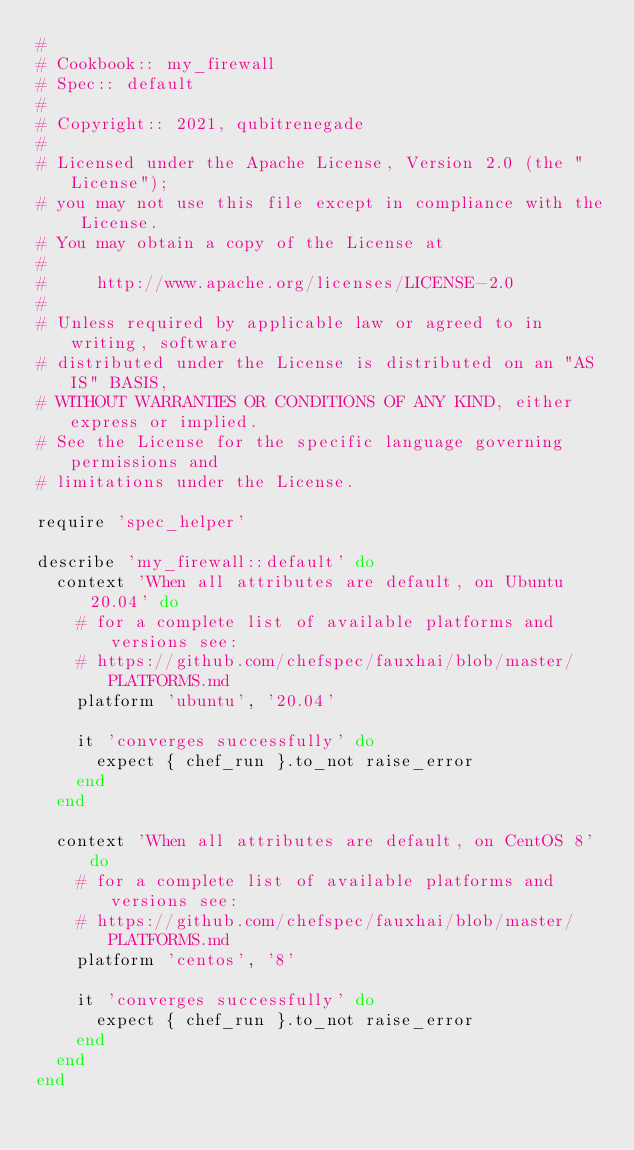<code> <loc_0><loc_0><loc_500><loc_500><_Ruby_>#
# Cookbook:: my_firewall
# Spec:: default
#
# Copyright:: 2021, qubitrenegade
#
# Licensed under the Apache License, Version 2.0 (the "License");
# you may not use this file except in compliance with the License.
# You may obtain a copy of the License at
#
#     http://www.apache.org/licenses/LICENSE-2.0
#
# Unless required by applicable law or agreed to in writing, software
# distributed under the License is distributed on an "AS IS" BASIS,
# WITHOUT WARRANTIES OR CONDITIONS OF ANY KIND, either express or implied.
# See the License for the specific language governing permissions and
# limitations under the License.

require 'spec_helper'

describe 'my_firewall::default' do
  context 'When all attributes are default, on Ubuntu 20.04' do
    # for a complete list of available platforms and versions see:
    # https://github.com/chefspec/fauxhai/blob/master/PLATFORMS.md
    platform 'ubuntu', '20.04'

    it 'converges successfully' do
      expect { chef_run }.to_not raise_error
    end
  end

  context 'When all attributes are default, on CentOS 8' do
    # for a complete list of available platforms and versions see:
    # https://github.com/chefspec/fauxhai/blob/master/PLATFORMS.md
    platform 'centos', '8'

    it 'converges successfully' do
      expect { chef_run }.to_not raise_error
    end
  end
end
</code> 